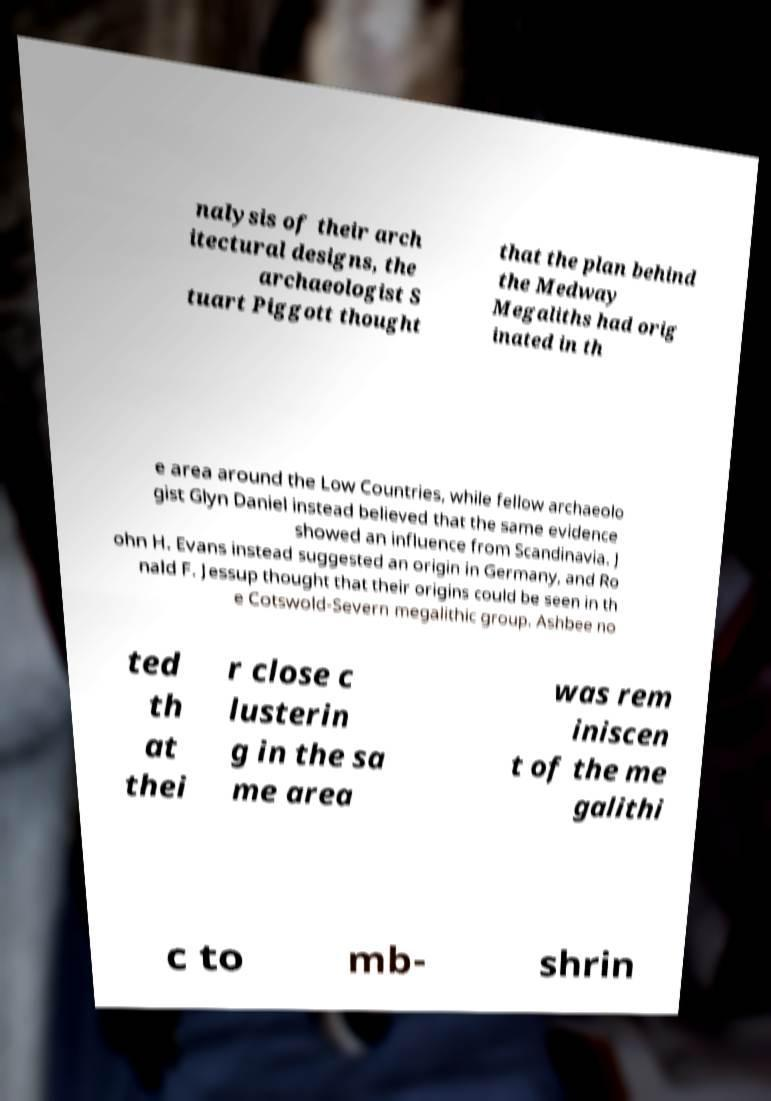Please read and relay the text visible in this image. What does it say? nalysis of their arch itectural designs, the archaeologist S tuart Piggott thought that the plan behind the Medway Megaliths had orig inated in th e area around the Low Countries, while fellow archaeolo gist Glyn Daniel instead believed that the same evidence showed an influence from Scandinavia. J ohn H. Evans instead suggested an origin in Germany, and Ro nald F. Jessup thought that their origins could be seen in th e Cotswold-Severn megalithic group. Ashbee no ted th at thei r close c lusterin g in the sa me area was rem iniscen t of the me galithi c to mb- shrin 